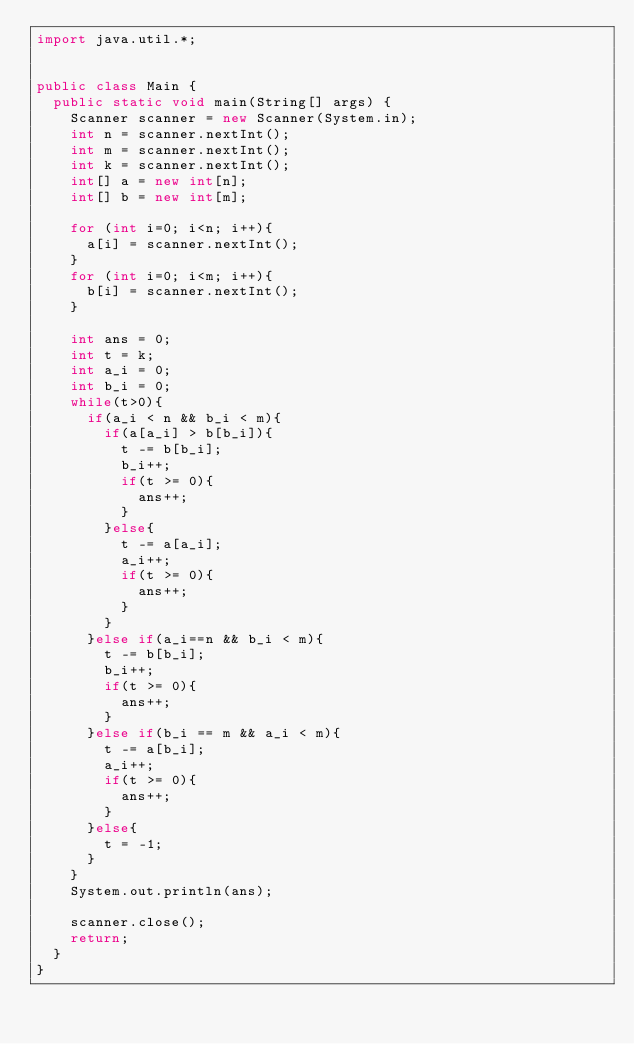<code> <loc_0><loc_0><loc_500><loc_500><_Java_>import java.util.*;


public class Main {
  public static void main(String[] args) {
    Scanner scanner = new Scanner(System.in);
    int n = scanner.nextInt();
    int m = scanner.nextInt();
    int k = scanner.nextInt();
    int[] a = new int[n];
    int[] b = new int[m];

    for (int i=0; i<n; i++){
      a[i] = scanner.nextInt();
    }
    for (int i=0; i<m; i++){
      b[i] = scanner.nextInt();
    }

    int ans = 0;
    int t = k;
    int a_i = 0;
    int b_i = 0;
    while(t>0){
      if(a_i < n && b_i < m){
        if(a[a_i] > b[b_i]){
          t -= b[b_i];
          b_i++;
          if(t >= 0){
            ans++;
          }
        }else{
          t -= a[a_i];
          a_i++;
          if(t >= 0){
            ans++;
          }
        }
      }else if(a_i==n && b_i < m){
        t -= b[b_i];
        b_i++;
        if(t >= 0){
          ans++;
        }
      }else if(b_i == m && a_i < m){
        t -= a[b_i];
        a_i++;
        if(t >= 0){
          ans++;
        }
      }else{
        t = -1;
      }
    }
    System.out.println(ans);
    
    scanner.close();
    return;
  }
}
</code> 